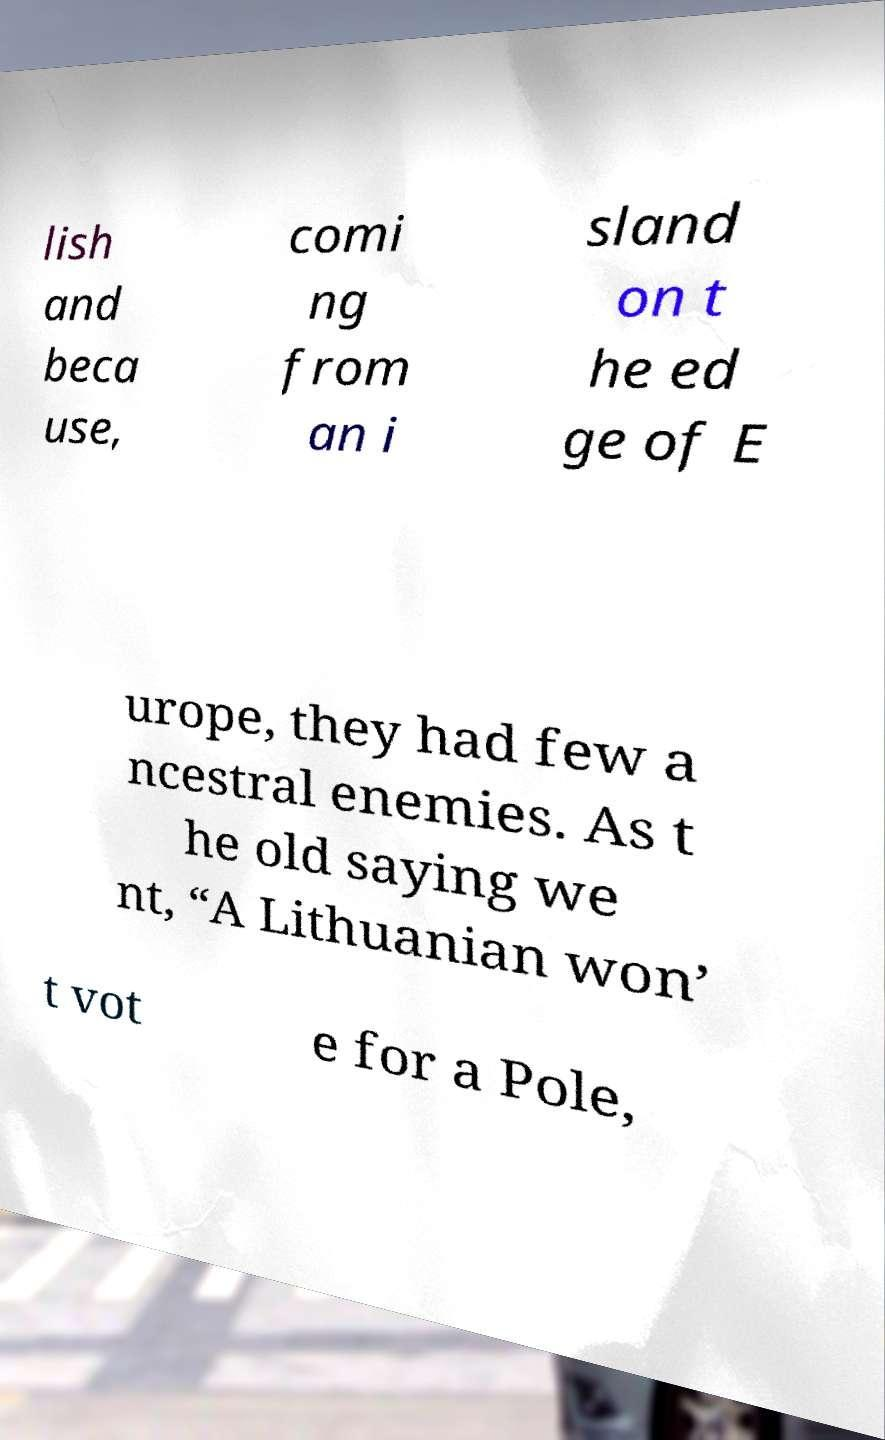What messages or text are displayed in this image? I need them in a readable, typed format. lish and beca use, comi ng from an i sland on t he ed ge of E urope, they had few a ncestral enemies. As t he old saying we nt, “A Lithuanian won’ t vot e for a Pole, 